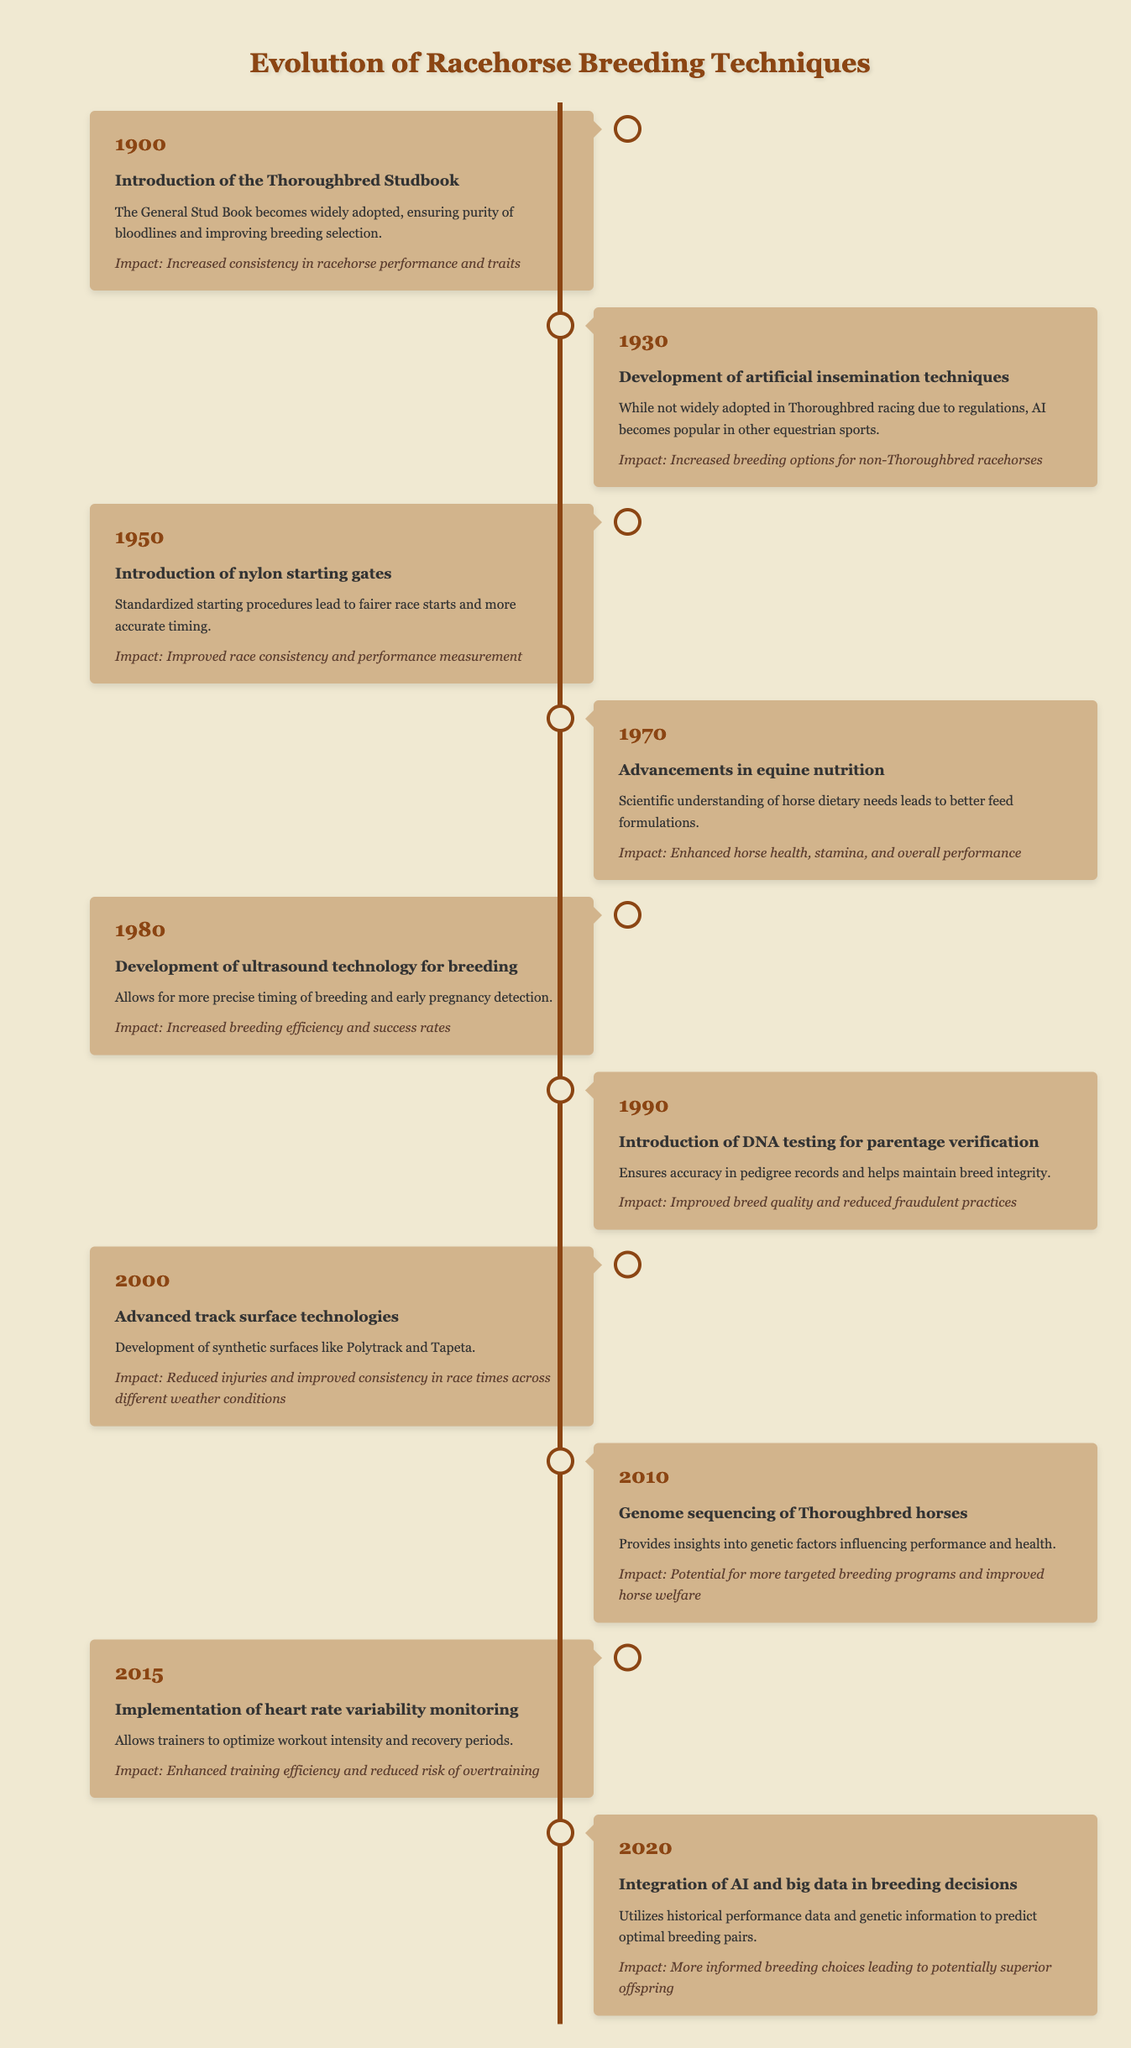What year was the DNA testing for parentage verification introduced? The table shows that DNA testing for parentage verification was introduced in the year 1990.
Answer: 1990 What was the event that occurred in 2000? According to the table, the event that occurred in 2000 was the introduction of advanced track surface technologies.
Answer: Advanced track surface technologies How many events listed in the timeline relate to advancements in technology? The events directly related to technological advancements are: Introduction of artificial insemination techniques (1930), Development of ultrasound technology for breeding (1980), Genome sequencing of Thoroughbred horses (2010), and Integration of AI and big data in breeding decisions (2020). That's a total of 4 events.
Answer: 4 Was the introduction of the Thoroughbred Studbook related to racehorse performance? Yes, according to the impact mentioned in the table, it increased consistency in racehorse performance and traits.
Answer: Yes Which event mentioned had the most significant impact on horse health and stamina? The event in 1970 regarding advancements in equine nutrition had the most significant impact, as it enhanced horse health, stamina, and overall performance.
Answer: Advancements in equine nutrition (1970) 